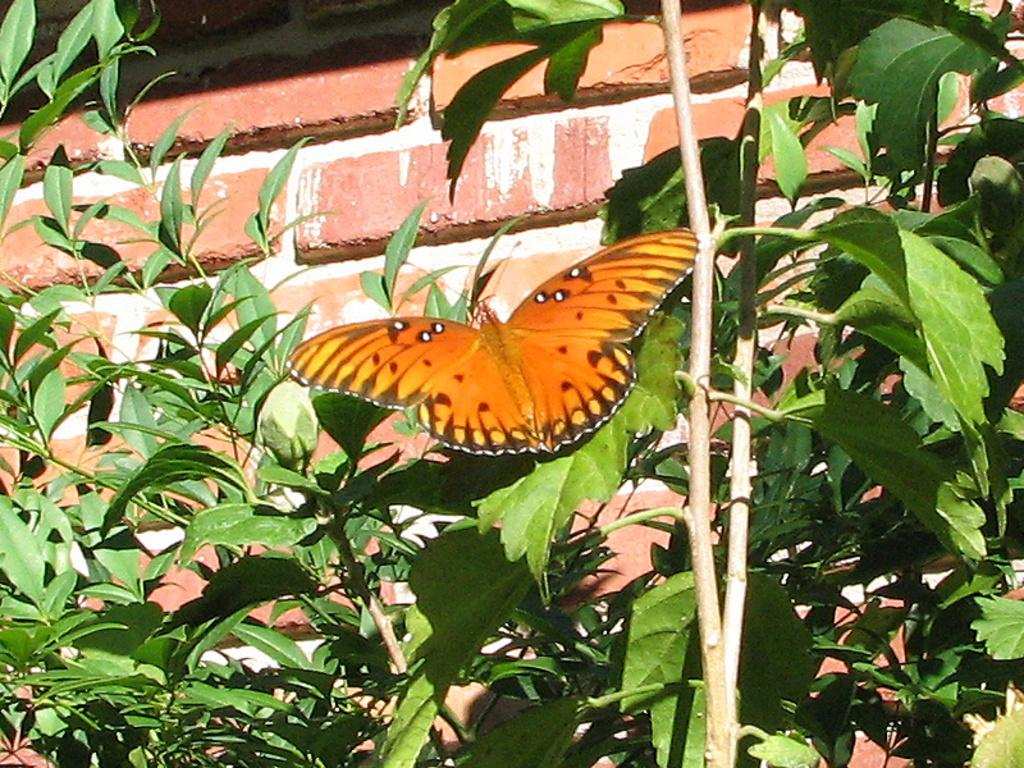What is the main subject in the center of the image? There is a butterfly in the center of the image. What can be seen in the background of the image? There are plants and bricks in the background of the image. What level of difficulty is the butterfly designed for in the image? The image does not indicate any level of difficulty or skill level for the butterfly. 